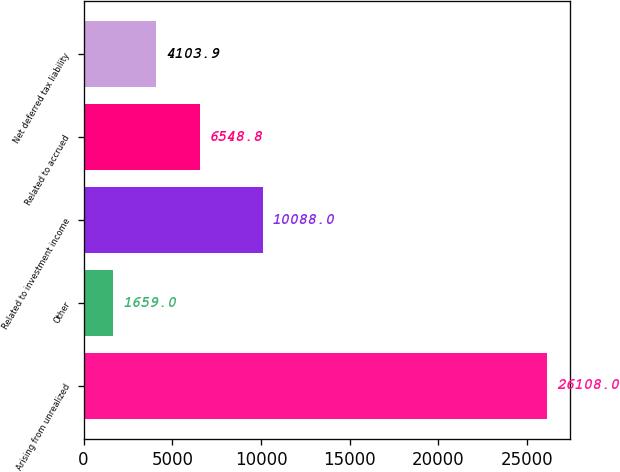<chart> <loc_0><loc_0><loc_500><loc_500><bar_chart><fcel>Arising from unrealized<fcel>Other<fcel>Related to investment income<fcel>Related to accrued<fcel>Net deferred tax liability<nl><fcel>26108<fcel>1659<fcel>10088<fcel>6548.8<fcel>4103.9<nl></chart> 